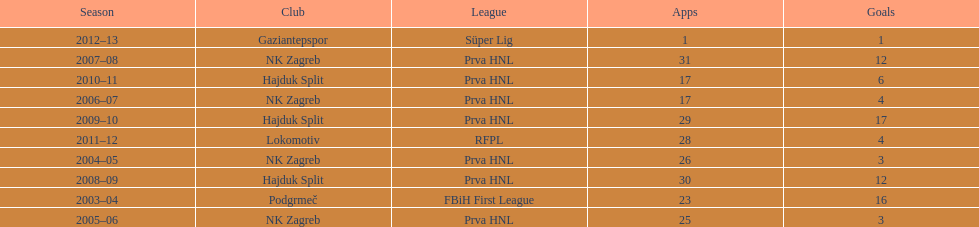Did ibricic score more or less goals in his 3 seasons with hajduk split when compared to his 4 seasons with nk zagreb? More. 